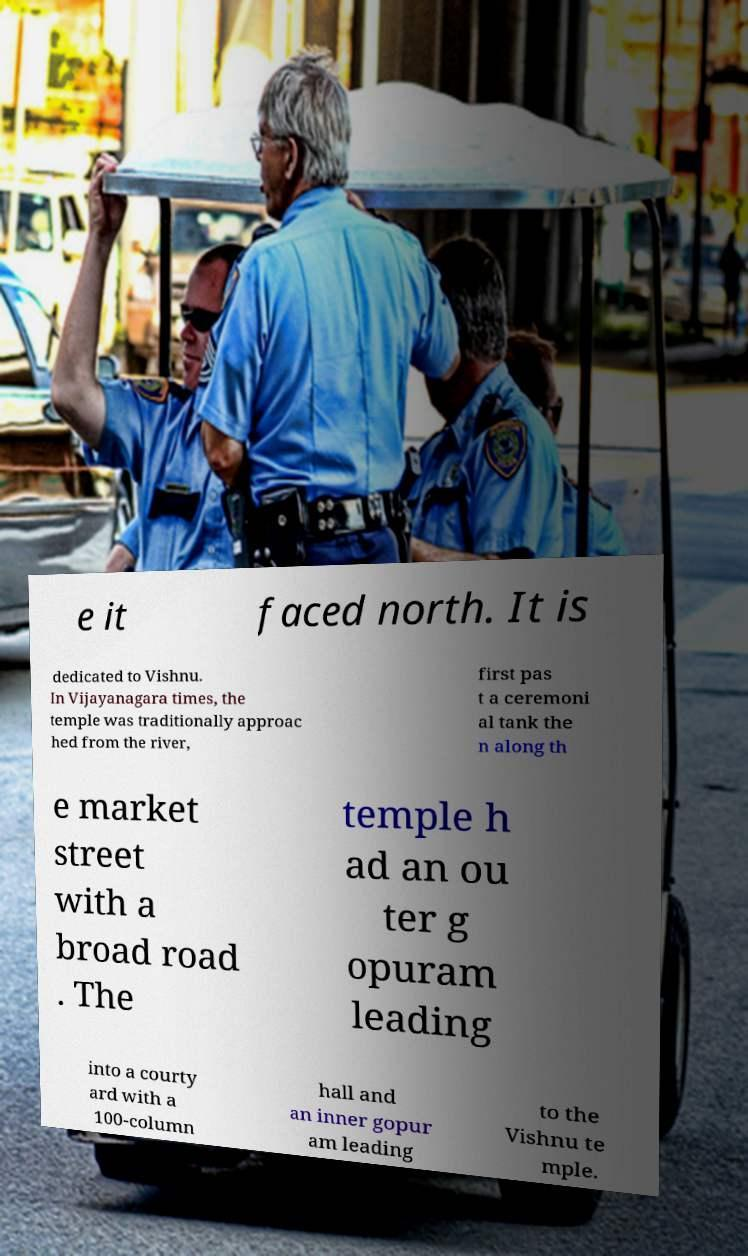There's text embedded in this image that I need extracted. Can you transcribe it verbatim? e it faced north. It is dedicated to Vishnu. In Vijayanagara times, the temple was traditionally approac hed from the river, first pas t a ceremoni al tank the n along th e market street with a broad road . The temple h ad an ou ter g opuram leading into a courty ard with a 100-column hall and an inner gopur am leading to the Vishnu te mple. 